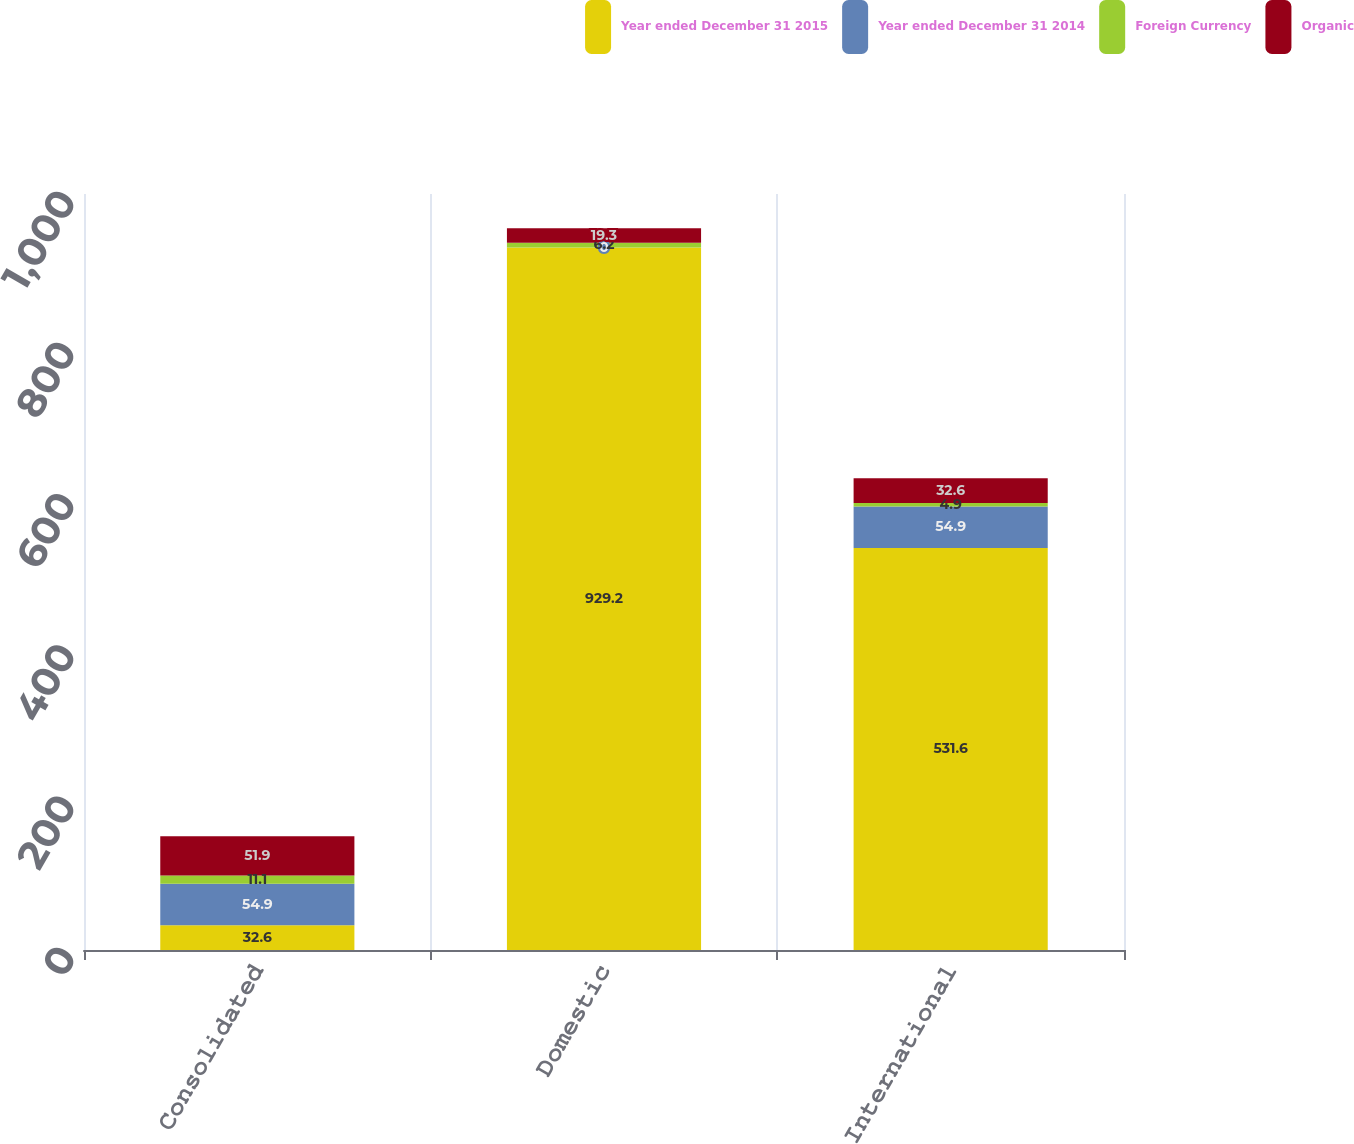Convert chart to OTSL. <chart><loc_0><loc_0><loc_500><loc_500><stacked_bar_chart><ecel><fcel>Consolidated<fcel>Domestic<fcel>International<nl><fcel>Year ended December 31 2015<fcel>32.6<fcel>929.2<fcel>531.6<nl><fcel>Year ended December 31 2014<fcel>54.9<fcel>0<fcel>54.9<nl><fcel>Foreign Currency<fcel>11.1<fcel>6.2<fcel>4.9<nl><fcel>Organic<fcel>51.9<fcel>19.3<fcel>32.6<nl></chart> 